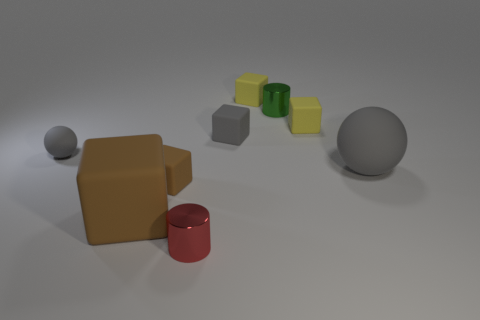How big is the gray rubber thing right of the small rubber object that is on the right side of the small green metallic cylinder?
Provide a short and direct response. Large. What number of other things are the same color as the small matte ball?
Provide a succinct answer. 2. What material is the tiny red object?
Keep it short and to the point. Metal. Are there any tiny red balls?
Keep it short and to the point. No. Are there the same number of big objects to the left of the small red object and tiny objects?
Your answer should be very brief. No. Is there any other thing that has the same material as the tiny gray sphere?
Make the answer very short. Yes. What number of small things are either yellow matte cubes or yellow rubber spheres?
Your answer should be compact. 2. The tiny object that is the same color as the big block is what shape?
Your answer should be compact. Cube. Is the material of the gray object that is left of the red shiny thing the same as the large brown thing?
Ensure brevity in your answer.  Yes. There is a small block to the right of the small green metallic cylinder that is on the left side of the big gray ball; what is it made of?
Offer a terse response. Rubber. 